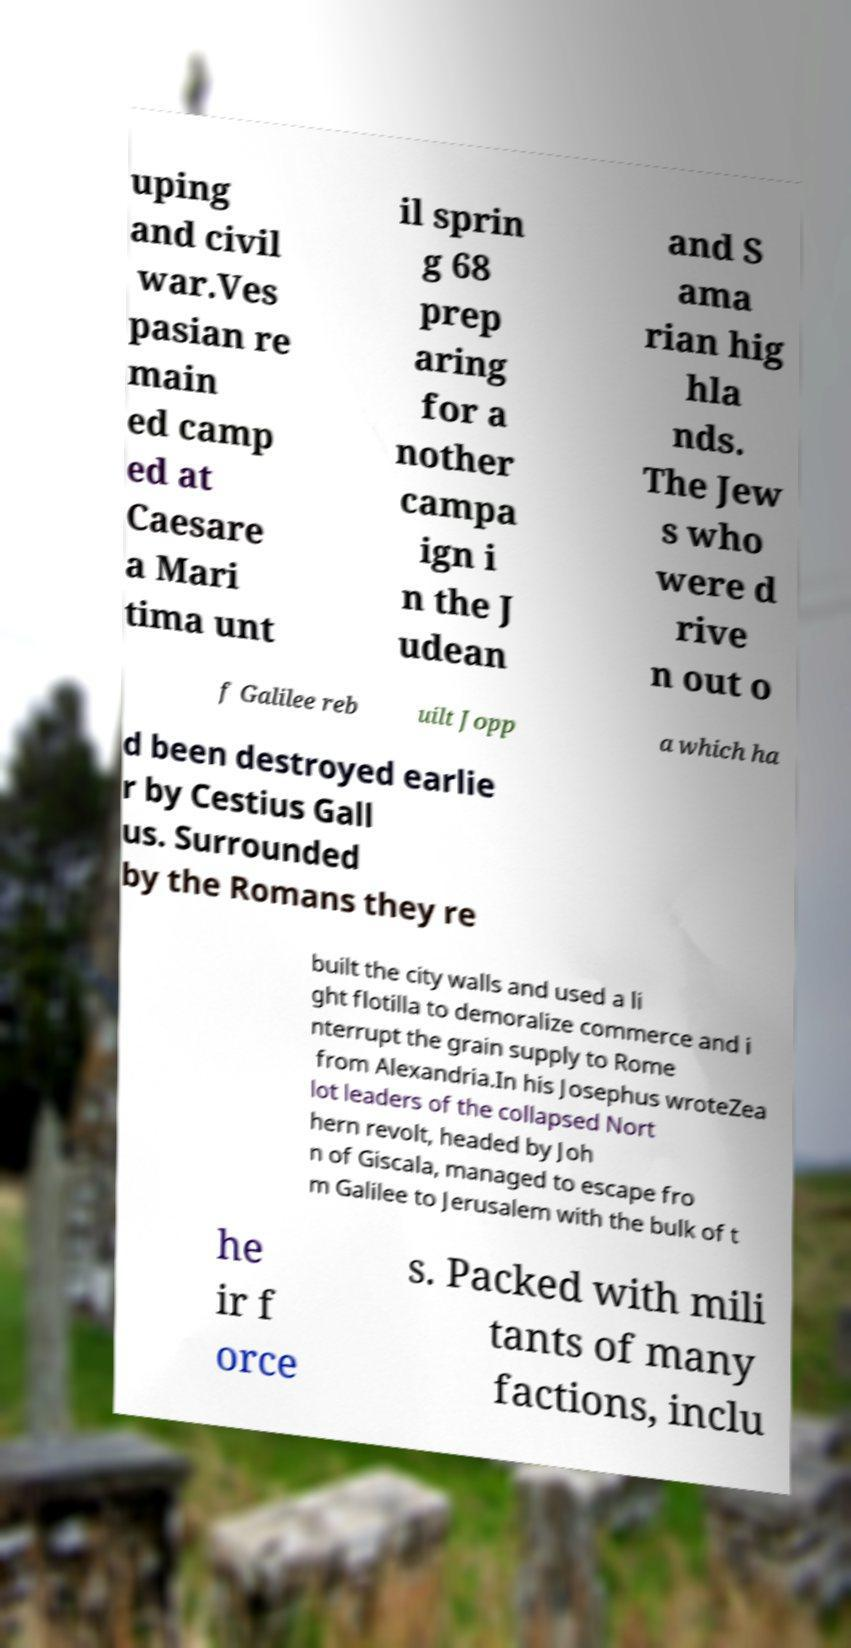Please read and relay the text visible in this image. What does it say? uping and civil war.Ves pasian re main ed camp ed at Caesare a Mari tima unt il sprin g 68 prep aring for a nother campa ign i n the J udean and S ama rian hig hla nds. The Jew s who were d rive n out o f Galilee reb uilt Jopp a which ha d been destroyed earlie r by Cestius Gall us. Surrounded by the Romans they re built the city walls and used a li ght flotilla to demoralize commerce and i nterrupt the grain supply to Rome from Alexandria.In his Josephus wroteZea lot leaders of the collapsed Nort hern revolt, headed by Joh n of Giscala, managed to escape fro m Galilee to Jerusalem with the bulk of t he ir f orce s. Packed with mili tants of many factions, inclu 